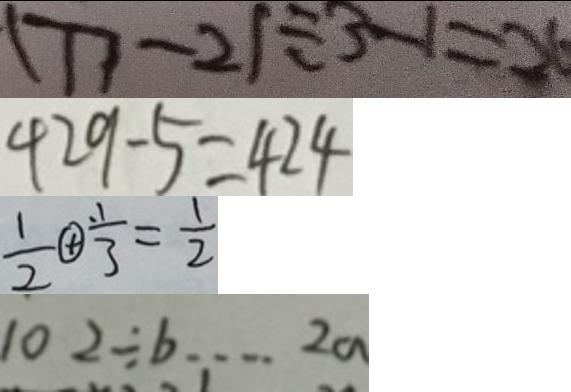Convert formula to latex. <formula><loc_0><loc_0><loc_500><loc_500>( 7 7 - 2 ) \div 3 - 1 = 2 6 
 4 2 9 - 5 = 4 2 4 
 \frac { 1 } { 2 } \textcircled { + } \frac { . 1 } { 3 } = \frac { 1 } { 2 } 
 1 0 2 \div b \cdots 2 a</formula> 